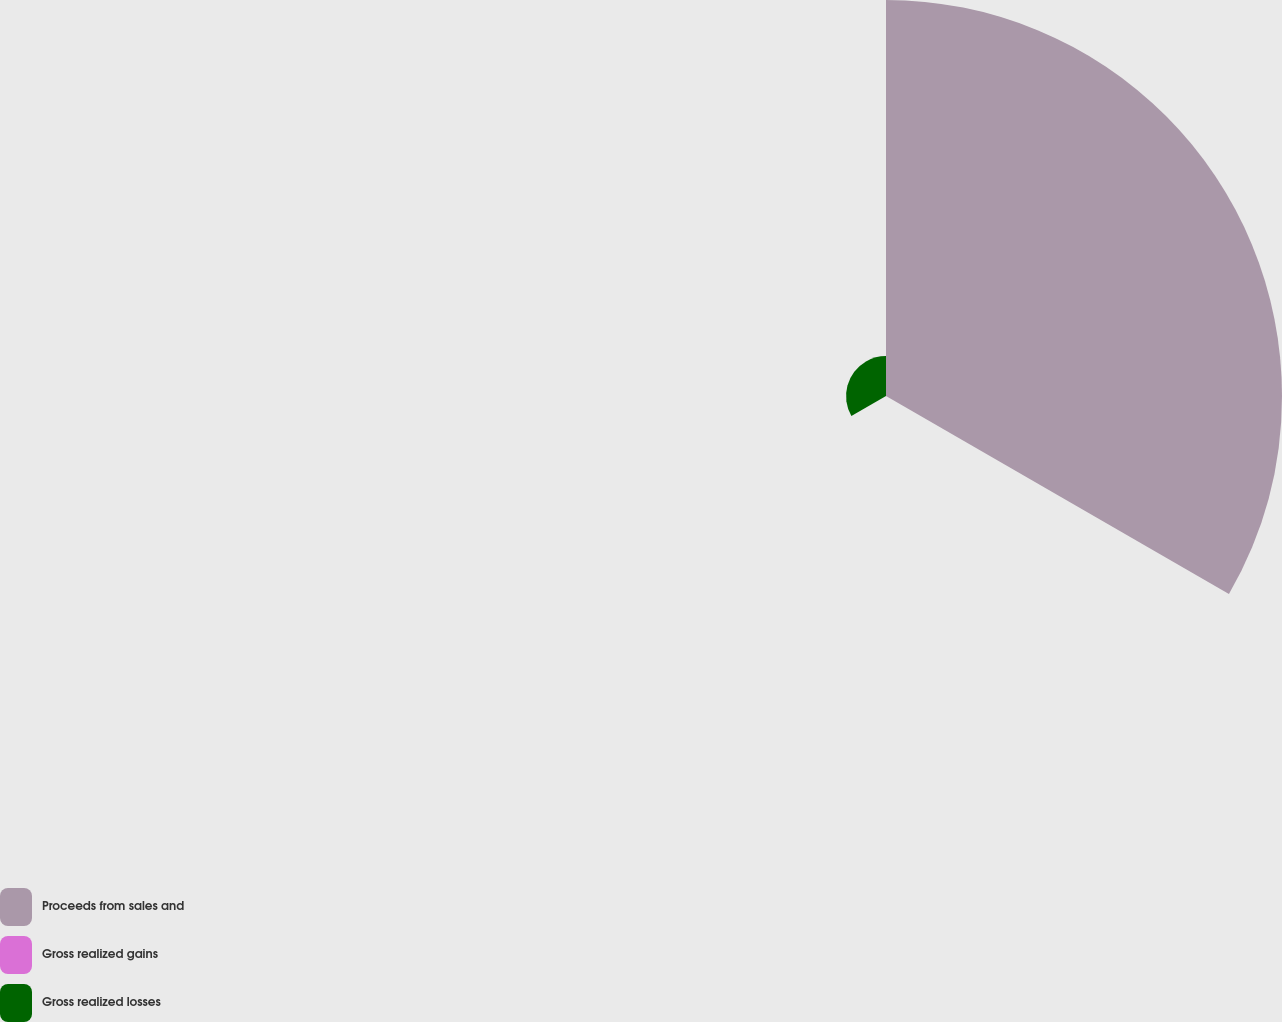<chart> <loc_0><loc_0><loc_500><loc_500><pie_chart><fcel>Proceeds from sales and<fcel>Gross realized gains<fcel>Gross realized losses<nl><fcel>90.75%<fcel>0.09%<fcel>9.16%<nl></chart> 